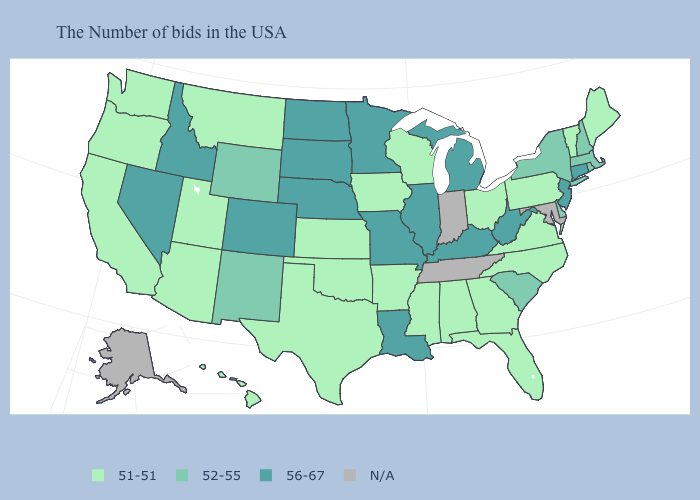Does the first symbol in the legend represent the smallest category?
Give a very brief answer. Yes. Name the states that have a value in the range 51-51?
Answer briefly. Maine, Vermont, Pennsylvania, Virginia, North Carolina, Ohio, Florida, Georgia, Alabama, Wisconsin, Mississippi, Arkansas, Iowa, Kansas, Oklahoma, Texas, Utah, Montana, Arizona, California, Washington, Oregon, Hawaii. What is the value of Florida?
Short answer required. 51-51. What is the value of Virginia?
Keep it brief. 51-51. Name the states that have a value in the range 51-51?
Write a very short answer. Maine, Vermont, Pennsylvania, Virginia, North Carolina, Ohio, Florida, Georgia, Alabama, Wisconsin, Mississippi, Arkansas, Iowa, Kansas, Oklahoma, Texas, Utah, Montana, Arizona, California, Washington, Oregon, Hawaii. What is the lowest value in states that border Utah?
Concise answer only. 51-51. What is the value of Virginia?
Answer briefly. 51-51. Among the states that border Massachusetts , which have the highest value?
Write a very short answer. Connecticut. Among the states that border Georgia , does Florida have the highest value?
Keep it brief. No. What is the value of Utah?
Be succinct. 51-51. What is the value of Alabama?
Give a very brief answer. 51-51. Name the states that have a value in the range 51-51?
Concise answer only. Maine, Vermont, Pennsylvania, Virginia, North Carolina, Ohio, Florida, Georgia, Alabama, Wisconsin, Mississippi, Arkansas, Iowa, Kansas, Oklahoma, Texas, Utah, Montana, Arizona, California, Washington, Oregon, Hawaii. What is the value of North Dakota?
Short answer required. 56-67. What is the value of Alabama?
Be succinct. 51-51. 